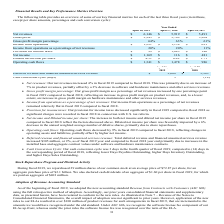From Netapp's financial document, Which years does the table provide information for some of the company's key financial metrics? The document contains multiple relevant values: 2019, 2018, 2017. From the document: "April 26, 2019 April 27, 2018 April 28, 2017 April 26, 2019 April 27, 2018 April 28, 2017 April 26, 2019 April 27, 2018 April 28, 2017..." Also, What was the gross profit for 2018? According to the financial document, 3,709 (in millions). The relevant text states: "Gross profit $ 3,945 $ 3,709 $ 3,364..." Also, What was the income from operations in 2017? According to the financial document, 621 (in millions). The relevant text states: "Income from operations $ 1,221 $ 1,158 $ 621..." Also, How many years did Gross profit margin percentage exceed 60%? Counting the relevant items in the document: 2019, 2018, 2017, I find 3 instances. The key data points involved are: 2017, 2018, 2019. Also, can you calculate: What was the percentage change in the net income between 2018 and 2019? To answer this question, I need to perform calculations using the financial data. The calculation is: (1,169-116)/116, which equals 907.76 (percentage). This is based on the information: "Net income $ 1,169 $ 116 $ 481 Net income $ 1,169 $ 116 $ 481..." The key data points involved are: 1,169, 116. Also, can you calculate: What was the change in operating cash flows between 2018 and 2019? Based on the calculation: 1,341-1,478, the result is -137 (in millions). This is based on the information: "Operating cash flows $ 1,341 $ 1,478 $ 986 Operating cash flows $ 1,341 $ 1,478 $ 986..." The key data points involved are: 1,341, 1,478. 